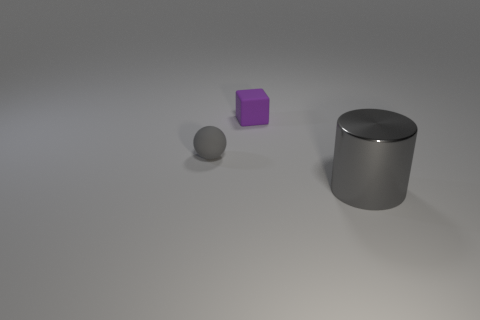What is the size of the other matte object that is the same color as the big object?
Provide a short and direct response. Small. The shiny object that is the same color as the tiny sphere is what shape?
Offer a terse response. Cylinder. Is there a gray rubber object of the same size as the rubber sphere?
Offer a very short reply. No. How many purple things are tiny blocks or spheres?
Your answer should be compact. 1. How many tiny balls have the same color as the tiny cube?
Your answer should be compact. 0. Is there anything else that is the same shape as the gray rubber object?
Your response must be concise. No. What number of cubes are large gray metal things or small cyan rubber objects?
Provide a succinct answer. 0. The tiny matte thing in front of the tiny purple rubber block is what color?
Provide a short and direct response. Gray. What is the shape of the thing that is the same size as the purple block?
Make the answer very short. Sphere. There is a metal thing; what number of gray spheres are in front of it?
Your answer should be very brief. 0. 